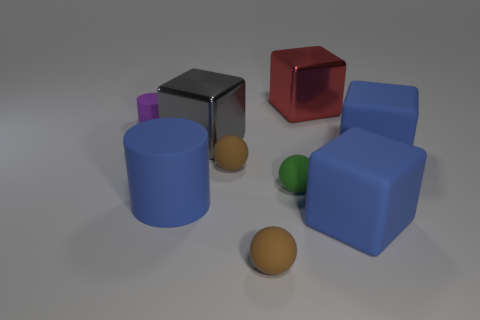Are there fewer blue matte cubes than cyan matte cylinders? Upon examination of the image, it appears that there is an equal number of blue matte cubes and cyan matte cylinders, with one of each present. 